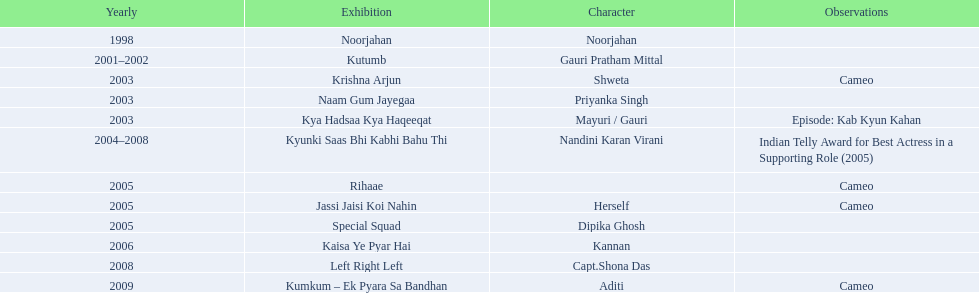What shows was gauri tejwani in? Noorjahan, Kutumb, Krishna Arjun, Naam Gum Jayegaa, Kya Hadsaa Kya Haqeeqat, Kyunki Saas Bhi Kabhi Bahu Thi, Rihaae, Jassi Jaisi Koi Nahin, Special Squad, Kaisa Ye Pyar Hai, Left Right Left, Kumkum – Ek Pyara Sa Bandhan. What were the 2005 shows? Rihaae, Jassi Jaisi Koi Nahin, Special Squad. Which were cameos? Rihaae, Jassi Jaisi Koi Nahin. Of which of these it was not rihaee? Jassi Jaisi Koi Nahin. 